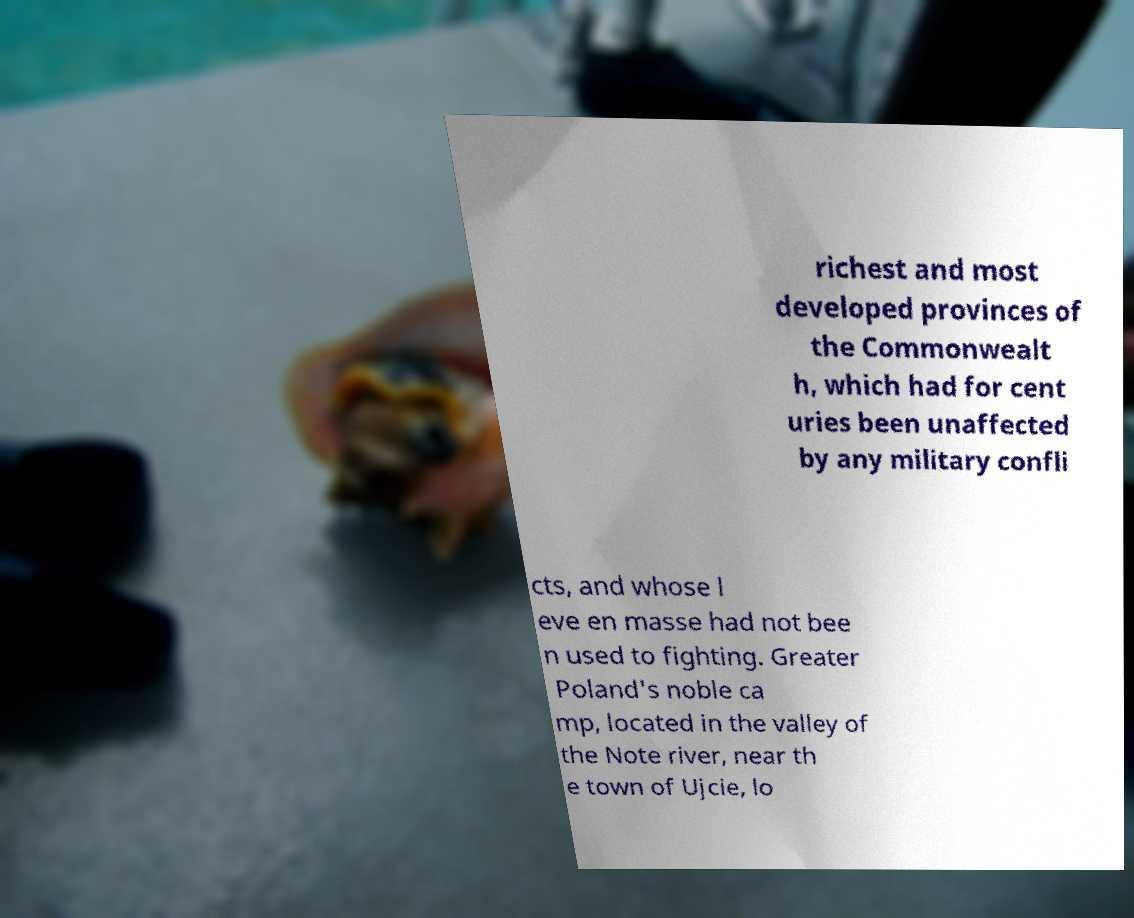Please identify and transcribe the text found in this image. richest and most developed provinces of the Commonwealt h, which had for cent uries been unaffected by any military confli cts, and whose l eve en masse had not bee n used to fighting. Greater Poland's noble ca mp, located in the valley of the Note river, near th e town of Ujcie, lo 